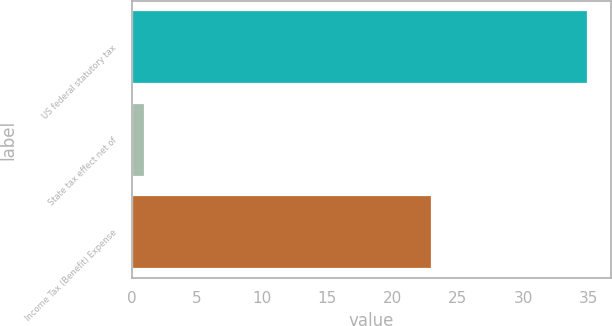Convert chart to OTSL. <chart><loc_0><loc_0><loc_500><loc_500><bar_chart><fcel>US federal statutory tax<fcel>State tax effect net of<fcel>Income Tax (Benefit) Expense<nl><fcel>35<fcel>1<fcel>23<nl></chart> 